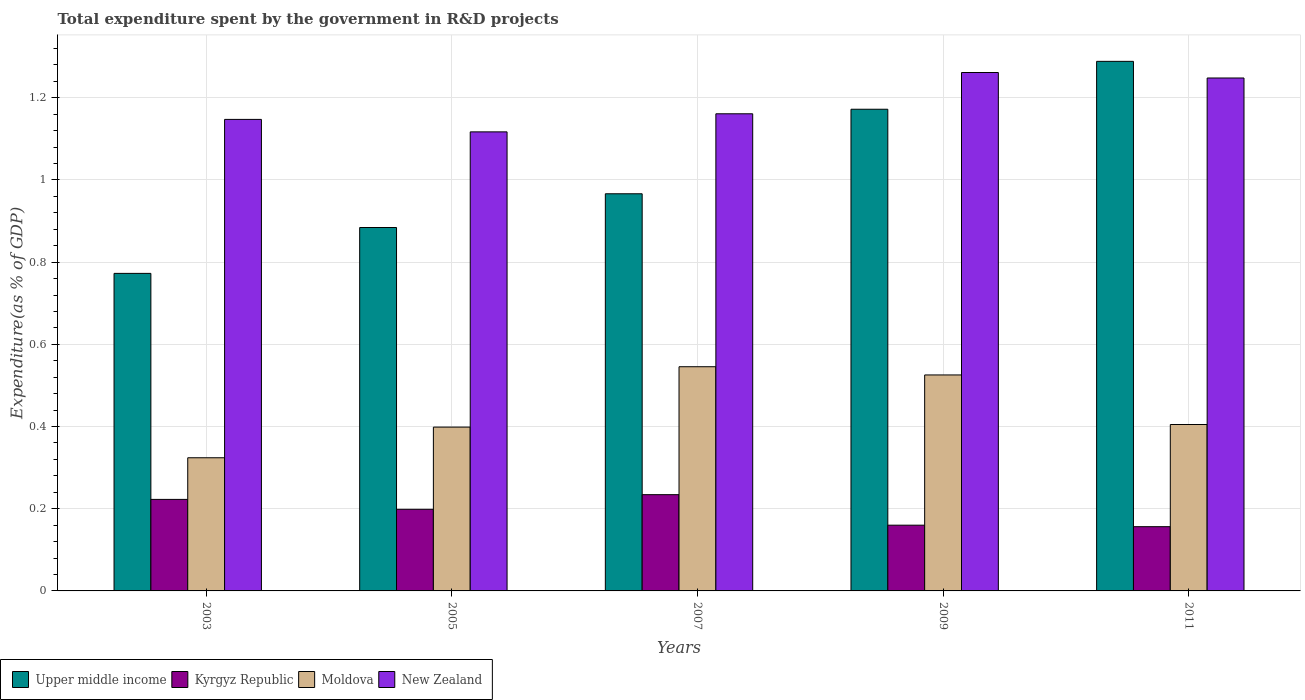How many different coloured bars are there?
Provide a short and direct response. 4. How many groups of bars are there?
Give a very brief answer. 5. Are the number of bars on each tick of the X-axis equal?
Make the answer very short. Yes. How many bars are there on the 1st tick from the left?
Offer a terse response. 4. How many bars are there on the 2nd tick from the right?
Provide a succinct answer. 4. What is the total expenditure spent by the government in R&D projects in Moldova in 2007?
Provide a short and direct response. 0.55. Across all years, what is the maximum total expenditure spent by the government in R&D projects in Upper middle income?
Offer a terse response. 1.29. Across all years, what is the minimum total expenditure spent by the government in R&D projects in Moldova?
Your answer should be compact. 0.32. In which year was the total expenditure spent by the government in R&D projects in Moldova maximum?
Provide a succinct answer. 2007. In which year was the total expenditure spent by the government in R&D projects in New Zealand minimum?
Give a very brief answer. 2005. What is the total total expenditure spent by the government in R&D projects in New Zealand in the graph?
Offer a very short reply. 5.94. What is the difference between the total expenditure spent by the government in R&D projects in Upper middle income in 2003 and that in 2011?
Make the answer very short. -0.52. What is the difference between the total expenditure spent by the government in R&D projects in Kyrgyz Republic in 2011 and the total expenditure spent by the government in R&D projects in Upper middle income in 2005?
Offer a very short reply. -0.73. What is the average total expenditure spent by the government in R&D projects in Moldova per year?
Give a very brief answer. 0.44. In the year 2005, what is the difference between the total expenditure spent by the government in R&D projects in Upper middle income and total expenditure spent by the government in R&D projects in New Zealand?
Your answer should be very brief. -0.23. What is the ratio of the total expenditure spent by the government in R&D projects in Upper middle income in 2007 to that in 2011?
Your response must be concise. 0.75. What is the difference between the highest and the second highest total expenditure spent by the government in R&D projects in Upper middle income?
Keep it short and to the point. 0.12. What is the difference between the highest and the lowest total expenditure spent by the government in R&D projects in Moldova?
Keep it short and to the point. 0.22. In how many years, is the total expenditure spent by the government in R&D projects in Moldova greater than the average total expenditure spent by the government in R&D projects in Moldova taken over all years?
Your answer should be compact. 2. Is the sum of the total expenditure spent by the government in R&D projects in Kyrgyz Republic in 2005 and 2009 greater than the maximum total expenditure spent by the government in R&D projects in Moldova across all years?
Provide a short and direct response. No. Is it the case that in every year, the sum of the total expenditure spent by the government in R&D projects in New Zealand and total expenditure spent by the government in R&D projects in Kyrgyz Republic is greater than the sum of total expenditure spent by the government in R&D projects in Moldova and total expenditure spent by the government in R&D projects in Upper middle income?
Your answer should be very brief. No. What does the 3rd bar from the left in 2003 represents?
Provide a succinct answer. Moldova. What does the 1st bar from the right in 2011 represents?
Give a very brief answer. New Zealand. Is it the case that in every year, the sum of the total expenditure spent by the government in R&D projects in Moldova and total expenditure spent by the government in R&D projects in Kyrgyz Republic is greater than the total expenditure spent by the government in R&D projects in Upper middle income?
Keep it short and to the point. No. How many bars are there?
Give a very brief answer. 20. Are all the bars in the graph horizontal?
Your response must be concise. No. How many years are there in the graph?
Make the answer very short. 5. Does the graph contain any zero values?
Provide a short and direct response. No. Does the graph contain grids?
Offer a terse response. Yes. Where does the legend appear in the graph?
Offer a terse response. Bottom left. How many legend labels are there?
Offer a terse response. 4. How are the legend labels stacked?
Offer a terse response. Horizontal. What is the title of the graph?
Your response must be concise. Total expenditure spent by the government in R&D projects. What is the label or title of the Y-axis?
Give a very brief answer. Expenditure(as % of GDP). What is the Expenditure(as % of GDP) of Upper middle income in 2003?
Give a very brief answer. 0.77. What is the Expenditure(as % of GDP) in Kyrgyz Republic in 2003?
Your response must be concise. 0.22. What is the Expenditure(as % of GDP) of Moldova in 2003?
Make the answer very short. 0.32. What is the Expenditure(as % of GDP) in New Zealand in 2003?
Offer a very short reply. 1.15. What is the Expenditure(as % of GDP) in Upper middle income in 2005?
Provide a succinct answer. 0.88. What is the Expenditure(as % of GDP) in Kyrgyz Republic in 2005?
Offer a very short reply. 0.2. What is the Expenditure(as % of GDP) of Moldova in 2005?
Your answer should be very brief. 0.4. What is the Expenditure(as % of GDP) of New Zealand in 2005?
Keep it short and to the point. 1.12. What is the Expenditure(as % of GDP) of Upper middle income in 2007?
Your answer should be very brief. 0.97. What is the Expenditure(as % of GDP) in Kyrgyz Republic in 2007?
Provide a succinct answer. 0.23. What is the Expenditure(as % of GDP) in Moldova in 2007?
Offer a terse response. 0.55. What is the Expenditure(as % of GDP) of New Zealand in 2007?
Keep it short and to the point. 1.16. What is the Expenditure(as % of GDP) in Upper middle income in 2009?
Make the answer very short. 1.17. What is the Expenditure(as % of GDP) of Kyrgyz Republic in 2009?
Provide a succinct answer. 0.16. What is the Expenditure(as % of GDP) in Moldova in 2009?
Give a very brief answer. 0.53. What is the Expenditure(as % of GDP) of New Zealand in 2009?
Give a very brief answer. 1.26. What is the Expenditure(as % of GDP) of Upper middle income in 2011?
Provide a short and direct response. 1.29. What is the Expenditure(as % of GDP) of Kyrgyz Republic in 2011?
Make the answer very short. 0.16. What is the Expenditure(as % of GDP) of Moldova in 2011?
Your response must be concise. 0.4. What is the Expenditure(as % of GDP) of New Zealand in 2011?
Offer a terse response. 1.25. Across all years, what is the maximum Expenditure(as % of GDP) in Upper middle income?
Offer a very short reply. 1.29. Across all years, what is the maximum Expenditure(as % of GDP) of Kyrgyz Republic?
Provide a short and direct response. 0.23. Across all years, what is the maximum Expenditure(as % of GDP) in Moldova?
Provide a succinct answer. 0.55. Across all years, what is the maximum Expenditure(as % of GDP) in New Zealand?
Provide a succinct answer. 1.26. Across all years, what is the minimum Expenditure(as % of GDP) of Upper middle income?
Your answer should be compact. 0.77. Across all years, what is the minimum Expenditure(as % of GDP) in Kyrgyz Republic?
Your answer should be compact. 0.16. Across all years, what is the minimum Expenditure(as % of GDP) in Moldova?
Provide a short and direct response. 0.32. Across all years, what is the minimum Expenditure(as % of GDP) of New Zealand?
Ensure brevity in your answer.  1.12. What is the total Expenditure(as % of GDP) of Upper middle income in the graph?
Offer a very short reply. 5.08. What is the total Expenditure(as % of GDP) of Kyrgyz Republic in the graph?
Your answer should be very brief. 0.97. What is the total Expenditure(as % of GDP) of Moldova in the graph?
Give a very brief answer. 2.2. What is the total Expenditure(as % of GDP) in New Zealand in the graph?
Your answer should be compact. 5.94. What is the difference between the Expenditure(as % of GDP) in Upper middle income in 2003 and that in 2005?
Your answer should be compact. -0.11. What is the difference between the Expenditure(as % of GDP) in Kyrgyz Republic in 2003 and that in 2005?
Provide a succinct answer. 0.02. What is the difference between the Expenditure(as % of GDP) in Moldova in 2003 and that in 2005?
Provide a short and direct response. -0.07. What is the difference between the Expenditure(as % of GDP) of New Zealand in 2003 and that in 2005?
Offer a very short reply. 0.03. What is the difference between the Expenditure(as % of GDP) in Upper middle income in 2003 and that in 2007?
Your response must be concise. -0.19. What is the difference between the Expenditure(as % of GDP) of Kyrgyz Republic in 2003 and that in 2007?
Provide a succinct answer. -0.01. What is the difference between the Expenditure(as % of GDP) of Moldova in 2003 and that in 2007?
Keep it short and to the point. -0.22. What is the difference between the Expenditure(as % of GDP) in New Zealand in 2003 and that in 2007?
Make the answer very short. -0.01. What is the difference between the Expenditure(as % of GDP) in Upper middle income in 2003 and that in 2009?
Offer a very short reply. -0.4. What is the difference between the Expenditure(as % of GDP) of Kyrgyz Republic in 2003 and that in 2009?
Your response must be concise. 0.06. What is the difference between the Expenditure(as % of GDP) of Moldova in 2003 and that in 2009?
Provide a succinct answer. -0.2. What is the difference between the Expenditure(as % of GDP) of New Zealand in 2003 and that in 2009?
Give a very brief answer. -0.11. What is the difference between the Expenditure(as % of GDP) in Upper middle income in 2003 and that in 2011?
Keep it short and to the point. -0.52. What is the difference between the Expenditure(as % of GDP) of Kyrgyz Republic in 2003 and that in 2011?
Offer a terse response. 0.07. What is the difference between the Expenditure(as % of GDP) of Moldova in 2003 and that in 2011?
Offer a terse response. -0.08. What is the difference between the Expenditure(as % of GDP) of New Zealand in 2003 and that in 2011?
Your response must be concise. -0.1. What is the difference between the Expenditure(as % of GDP) in Upper middle income in 2005 and that in 2007?
Offer a very short reply. -0.08. What is the difference between the Expenditure(as % of GDP) of Kyrgyz Republic in 2005 and that in 2007?
Your response must be concise. -0.04. What is the difference between the Expenditure(as % of GDP) in Moldova in 2005 and that in 2007?
Your answer should be very brief. -0.15. What is the difference between the Expenditure(as % of GDP) of New Zealand in 2005 and that in 2007?
Give a very brief answer. -0.04. What is the difference between the Expenditure(as % of GDP) in Upper middle income in 2005 and that in 2009?
Give a very brief answer. -0.29. What is the difference between the Expenditure(as % of GDP) of Kyrgyz Republic in 2005 and that in 2009?
Your answer should be very brief. 0.04. What is the difference between the Expenditure(as % of GDP) of Moldova in 2005 and that in 2009?
Give a very brief answer. -0.13. What is the difference between the Expenditure(as % of GDP) of New Zealand in 2005 and that in 2009?
Your answer should be compact. -0.14. What is the difference between the Expenditure(as % of GDP) of Upper middle income in 2005 and that in 2011?
Offer a very short reply. -0.4. What is the difference between the Expenditure(as % of GDP) in Kyrgyz Republic in 2005 and that in 2011?
Give a very brief answer. 0.04. What is the difference between the Expenditure(as % of GDP) of Moldova in 2005 and that in 2011?
Offer a terse response. -0.01. What is the difference between the Expenditure(as % of GDP) of New Zealand in 2005 and that in 2011?
Offer a very short reply. -0.13. What is the difference between the Expenditure(as % of GDP) in Upper middle income in 2007 and that in 2009?
Make the answer very short. -0.21. What is the difference between the Expenditure(as % of GDP) of Kyrgyz Republic in 2007 and that in 2009?
Ensure brevity in your answer.  0.07. What is the difference between the Expenditure(as % of GDP) of Moldova in 2007 and that in 2009?
Offer a very short reply. 0.02. What is the difference between the Expenditure(as % of GDP) in New Zealand in 2007 and that in 2009?
Provide a succinct answer. -0.1. What is the difference between the Expenditure(as % of GDP) in Upper middle income in 2007 and that in 2011?
Give a very brief answer. -0.32. What is the difference between the Expenditure(as % of GDP) of Kyrgyz Republic in 2007 and that in 2011?
Keep it short and to the point. 0.08. What is the difference between the Expenditure(as % of GDP) in Moldova in 2007 and that in 2011?
Offer a terse response. 0.14. What is the difference between the Expenditure(as % of GDP) of New Zealand in 2007 and that in 2011?
Offer a terse response. -0.09. What is the difference between the Expenditure(as % of GDP) of Upper middle income in 2009 and that in 2011?
Make the answer very short. -0.12. What is the difference between the Expenditure(as % of GDP) of Kyrgyz Republic in 2009 and that in 2011?
Provide a short and direct response. 0. What is the difference between the Expenditure(as % of GDP) of Moldova in 2009 and that in 2011?
Make the answer very short. 0.12. What is the difference between the Expenditure(as % of GDP) of New Zealand in 2009 and that in 2011?
Provide a succinct answer. 0.01. What is the difference between the Expenditure(as % of GDP) of Upper middle income in 2003 and the Expenditure(as % of GDP) of Kyrgyz Republic in 2005?
Your answer should be very brief. 0.57. What is the difference between the Expenditure(as % of GDP) in Upper middle income in 2003 and the Expenditure(as % of GDP) in Moldova in 2005?
Offer a very short reply. 0.37. What is the difference between the Expenditure(as % of GDP) in Upper middle income in 2003 and the Expenditure(as % of GDP) in New Zealand in 2005?
Your response must be concise. -0.34. What is the difference between the Expenditure(as % of GDP) in Kyrgyz Republic in 2003 and the Expenditure(as % of GDP) in Moldova in 2005?
Provide a succinct answer. -0.18. What is the difference between the Expenditure(as % of GDP) of Kyrgyz Republic in 2003 and the Expenditure(as % of GDP) of New Zealand in 2005?
Provide a succinct answer. -0.89. What is the difference between the Expenditure(as % of GDP) of Moldova in 2003 and the Expenditure(as % of GDP) of New Zealand in 2005?
Give a very brief answer. -0.79. What is the difference between the Expenditure(as % of GDP) in Upper middle income in 2003 and the Expenditure(as % of GDP) in Kyrgyz Republic in 2007?
Provide a short and direct response. 0.54. What is the difference between the Expenditure(as % of GDP) in Upper middle income in 2003 and the Expenditure(as % of GDP) in Moldova in 2007?
Your response must be concise. 0.23. What is the difference between the Expenditure(as % of GDP) in Upper middle income in 2003 and the Expenditure(as % of GDP) in New Zealand in 2007?
Make the answer very short. -0.39. What is the difference between the Expenditure(as % of GDP) of Kyrgyz Republic in 2003 and the Expenditure(as % of GDP) of Moldova in 2007?
Provide a succinct answer. -0.32. What is the difference between the Expenditure(as % of GDP) of Kyrgyz Republic in 2003 and the Expenditure(as % of GDP) of New Zealand in 2007?
Offer a terse response. -0.94. What is the difference between the Expenditure(as % of GDP) of Moldova in 2003 and the Expenditure(as % of GDP) of New Zealand in 2007?
Your answer should be compact. -0.84. What is the difference between the Expenditure(as % of GDP) of Upper middle income in 2003 and the Expenditure(as % of GDP) of Kyrgyz Republic in 2009?
Keep it short and to the point. 0.61. What is the difference between the Expenditure(as % of GDP) of Upper middle income in 2003 and the Expenditure(as % of GDP) of Moldova in 2009?
Your answer should be compact. 0.25. What is the difference between the Expenditure(as % of GDP) in Upper middle income in 2003 and the Expenditure(as % of GDP) in New Zealand in 2009?
Your response must be concise. -0.49. What is the difference between the Expenditure(as % of GDP) in Kyrgyz Republic in 2003 and the Expenditure(as % of GDP) in Moldova in 2009?
Offer a very short reply. -0.3. What is the difference between the Expenditure(as % of GDP) of Kyrgyz Republic in 2003 and the Expenditure(as % of GDP) of New Zealand in 2009?
Offer a terse response. -1.04. What is the difference between the Expenditure(as % of GDP) in Moldova in 2003 and the Expenditure(as % of GDP) in New Zealand in 2009?
Provide a succinct answer. -0.94. What is the difference between the Expenditure(as % of GDP) of Upper middle income in 2003 and the Expenditure(as % of GDP) of Kyrgyz Republic in 2011?
Keep it short and to the point. 0.62. What is the difference between the Expenditure(as % of GDP) of Upper middle income in 2003 and the Expenditure(as % of GDP) of Moldova in 2011?
Provide a short and direct response. 0.37. What is the difference between the Expenditure(as % of GDP) of Upper middle income in 2003 and the Expenditure(as % of GDP) of New Zealand in 2011?
Ensure brevity in your answer.  -0.48. What is the difference between the Expenditure(as % of GDP) in Kyrgyz Republic in 2003 and the Expenditure(as % of GDP) in Moldova in 2011?
Your answer should be compact. -0.18. What is the difference between the Expenditure(as % of GDP) in Kyrgyz Republic in 2003 and the Expenditure(as % of GDP) in New Zealand in 2011?
Keep it short and to the point. -1.03. What is the difference between the Expenditure(as % of GDP) of Moldova in 2003 and the Expenditure(as % of GDP) of New Zealand in 2011?
Provide a short and direct response. -0.92. What is the difference between the Expenditure(as % of GDP) in Upper middle income in 2005 and the Expenditure(as % of GDP) in Kyrgyz Republic in 2007?
Your answer should be compact. 0.65. What is the difference between the Expenditure(as % of GDP) of Upper middle income in 2005 and the Expenditure(as % of GDP) of Moldova in 2007?
Ensure brevity in your answer.  0.34. What is the difference between the Expenditure(as % of GDP) of Upper middle income in 2005 and the Expenditure(as % of GDP) of New Zealand in 2007?
Your answer should be compact. -0.28. What is the difference between the Expenditure(as % of GDP) in Kyrgyz Republic in 2005 and the Expenditure(as % of GDP) in Moldova in 2007?
Keep it short and to the point. -0.35. What is the difference between the Expenditure(as % of GDP) of Kyrgyz Republic in 2005 and the Expenditure(as % of GDP) of New Zealand in 2007?
Provide a succinct answer. -0.96. What is the difference between the Expenditure(as % of GDP) of Moldova in 2005 and the Expenditure(as % of GDP) of New Zealand in 2007?
Offer a terse response. -0.76. What is the difference between the Expenditure(as % of GDP) in Upper middle income in 2005 and the Expenditure(as % of GDP) in Kyrgyz Republic in 2009?
Offer a terse response. 0.72. What is the difference between the Expenditure(as % of GDP) of Upper middle income in 2005 and the Expenditure(as % of GDP) of Moldova in 2009?
Your answer should be very brief. 0.36. What is the difference between the Expenditure(as % of GDP) of Upper middle income in 2005 and the Expenditure(as % of GDP) of New Zealand in 2009?
Provide a short and direct response. -0.38. What is the difference between the Expenditure(as % of GDP) of Kyrgyz Republic in 2005 and the Expenditure(as % of GDP) of Moldova in 2009?
Give a very brief answer. -0.33. What is the difference between the Expenditure(as % of GDP) in Kyrgyz Republic in 2005 and the Expenditure(as % of GDP) in New Zealand in 2009?
Give a very brief answer. -1.06. What is the difference between the Expenditure(as % of GDP) in Moldova in 2005 and the Expenditure(as % of GDP) in New Zealand in 2009?
Offer a terse response. -0.86. What is the difference between the Expenditure(as % of GDP) of Upper middle income in 2005 and the Expenditure(as % of GDP) of Kyrgyz Republic in 2011?
Your response must be concise. 0.73. What is the difference between the Expenditure(as % of GDP) in Upper middle income in 2005 and the Expenditure(as % of GDP) in Moldova in 2011?
Your answer should be compact. 0.48. What is the difference between the Expenditure(as % of GDP) of Upper middle income in 2005 and the Expenditure(as % of GDP) of New Zealand in 2011?
Your answer should be very brief. -0.36. What is the difference between the Expenditure(as % of GDP) in Kyrgyz Republic in 2005 and the Expenditure(as % of GDP) in Moldova in 2011?
Provide a short and direct response. -0.21. What is the difference between the Expenditure(as % of GDP) of Kyrgyz Republic in 2005 and the Expenditure(as % of GDP) of New Zealand in 2011?
Offer a very short reply. -1.05. What is the difference between the Expenditure(as % of GDP) of Moldova in 2005 and the Expenditure(as % of GDP) of New Zealand in 2011?
Ensure brevity in your answer.  -0.85. What is the difference between the Expenditure(as % of GDP) of Upper middle income in 2007 and the Expenditure(as % of GDP) of Kyrgyz Republic in 2009?
Offer a terse response. 0.81. What is the difference between the Expenditure(as % of GDP) in Upper middle income in 2007 and the Expenditure(as % of GDP) in Moldova in 2009?
Your response must be concise. 0.44. What is the difference between the Expenditure(as % of GDP) of Upper middle income in 2007 and the Expenditure(as % of GDP) of New Zealand in 2009?
Ensure brevity in your answer.  -0.3. What is the difference between the Expenditure(as % of GDP) of Kyrgyz Republic in 2007 and the Expenditure(as % of GDP) of Moldova in 2009?
Provide a succinct answer. -0.29. What is the difference between the Expenditure(as % of GDP) in Kyrgyz Republic in 2007 and the Expenditure(as % of GDP) in New Zealand in 2009?
Make the answer very short. -1.03. What is the difference between the Expenditure(as % of GDP) in Moldova in 2007 and the Expenditure(as % of GDP) in New Zealand in 2009?
Provide a succinct answer. -0.72. What is the difference between the Expenditure(as % of GDP) in Upper middle income in 2007 and the Expenditure(as % of GDP) in Kyrgyz Republic in 2011?
Make the answer very short. 0.81. What is the difference between the Expenditure(as % of GDP) of Upper middle income in 2007 and the Expenditure(as % of GDP) of Moldova in 2011?
Ensure brevity in your answer.  0.56. What is the difference between the Expenditure(as % of GDP) of Upper middle income in 2007 and the Expenditure(as % of GDP) of New Zealand in 2011?
Offer a terse response. -0.28. What is the difference between the Expenditure(as % of GDP) of Kyrgyz Republic in 2007 and the Expenditure(as % of GDP) of Moldova in 2011?
Give a very brief answer. -0.17. What is the difference between the Expenditure(as % of GDP) of Kyrgyz Republic in 2007 and the Expenditure(as % of GDP) of New Zealand in 2011?
Offer a very short reply. -1.01. What is the difference between the Expenditure(as % of GDP) of Moldova in 2007 and the Expenditure(as % of GDP) of New Zealand in 2011?
Offer a terse response. -0.7. What is the difference between the Expenditure(as % of GDP) in Upper middle income in 2009 and the Expenditure(as % of GDP) in Kyrgyz Republic in 2011?
Provide a succinct answer. 1.02. What is the difference between the Expenditure(as % of GDP) of Upper middle income in 2009 and the Expenditure(as % of GDP) of Moldova in 2011?
Keep it short and to the point. 0.77. What is the difference between the Expenditure(as % of GDP) of Upper middle income in 2009 and the Expenditure(as % of GDP) of New Zealand in 2011?
Keep it short and to the point. -0.08. What is the difference between the Expenditure(as % of GDP) of Kyrgyz Republic in 2009 and the Expenditure(as % of GDP) of Moldova in 2011?
Provide a short and direct response. -0.24. What is the difference between the Expenditure(as % of GDP) of Kyrgyz Republic in 2009 and the Expenditure(as % of GDP) of New Zealand in 2011?
Offer a terse response. -1.09. What is the difference between the Expenditure(as % of GDP) in Moldova in 2009 and the Expenditure(as % of GDP) in New Zealand in 2011?
Offer a terse response. -0.72. What is the average Expenditure(as % of GDP) in Upper middle income per year?
Provide a short and direct response. 1.02. What is the average Expenditure(as % of GDP) in Kyrgyz Republic per year?
Give a very brief answer. 0.19. What is the average Expenditure(as % of GDP) of Moldova per year?
Your response must be concise. 0.44. What is the average Expenditure(as % of GDP) in New Zealand per year?
Make the answer very short. 1.19. In the year 2003, what is the difference between the Expenditure(as % of GDP) in Upper middle income and Expenditure(as % of GDP) in Kyrgyz Republic?
Provide a short and direct response. 0.55. In the year 2003, what is the difference between the Expenditure(as % of GDP) of Upper middle income and Expenditure(as % of GDP) of Moldova?
Keep it short and to the point. 0.45. In the year 2003, what is the difference between the Expenditure(as % of GDP) in Upper middle income and Expenditure(as % of GDP) in New Zealand?
Your answer should be compact. -0.37. In the year 2003, what is the difference between the Expenditure(as % of GDP) of Kyrgyz Republic and Expenditure(as % of GDP) of Moldova?
Ensure brevity in your answer.  -0.1. In the year 2003, what is the difference between the Expenditure(as % of GDP) in Kyrgyz Republic and Expenditure(as % of GDP) in New Zealand?
Make the answer very short. -0.92. In the year 2003, what is the difference between the Expenditure(as % of GDP) of Moldova and Expenditure(as % of GDP) of New Zealand?
Keep it short and to the point. -0.82. In the year 2005, what is the difference between the Expenditure(as % of GDP) in Upper middle income and Expenditure(as % of GDP) in Kyrgyz Republic?
Provide a short and direct response. 0.69. In the year 2005, what is the difference between the Expenditure(as % of GDP) in Upper middle income and Expenditure(as % of GDP) in Moldova?
Provide a succinct answer. 0.49. In the year 2005, what is the difference between the Expenditure(as % of GDP) in Upper middle income and Expenditure(as % of GDP) in New Zealand?
Your answer should be compact. -0.23. In the year 2005, what is the difference between the Expenditure(as % of GDP) in Kyrgyz Republic and Expenditure(as % of GDP) in Moldova?
Make the answer very short. -0.2. In the year 2005, what is the difference between the Expenditure(as % of GDP) in Kyrgyz Republic and Expenditure(as % of GDP) in New Zealand?
Your answer should be very brief. -0.92. In the year 2005, what is the difference between the Expenditure(as % of GDP) in Moldova and Expenditure(as % of GDP) in New Zealand?
Your answer should be compact. -0.72. In the year 2007, what is the difference between the Expenditure(as % of GDP) of Upper middle income and Expenditure(as % of GDP) of Kyrgyz Republic?
Your answer should be compact. 0.73. In the year 2007, what is the difference between the Expenditure(as % of GDP) in Upper middle income and Expenditure(as % of GDP) in Moldova?
Your answer should be very brief. 0.42. In the year 2007, what is the difference between the Expenditure(as % of GDP) of Upper middle income and Expenditure(as % of GDP) of New Zealand?
Your response must be concise. -0.19. In the year 2007, what is the difference between the Expenditure(as % of GDP) of Kyrgyz Republic and Expenditure(as % of GDP) of Moldova?
Make the answer very short. -0.31. In the year 2007, what is the difference between the Expenditure(as % of GDP) of Kyrgyz Republic and Expenditure(as % of GDP) of New Zealand?
Provide a succinct answer. -0.93. In the year 2007, what is the difference between the Expenditure(as % of GDP) in Moldova and Expenditure(as % of GDP) in New Zealand?
Your answer should be very brief. -0.62. In the year 2009, what is the difference between the Expenditure(as % of GDP) in Upper middle income and Expenditure(as % of GDP) in Kyrgyz Republic?
Provide a short and direct response. 1.01. In the year 2009, what is the difference between the Expenditure(as % of GDP) of Upper middle income and Expenditure(as % of GDP) of Moldova?
Keep it short and to the point. 0.65. In the year 2009, what is the difference between the Expenditure(as % of GDP) of Upper middle income and Expenditure(as % of GDP) of New Zealand?
Keep it short and to the point. -0.09. In the year 2009, what is the difference between the Expenditure(as % of GDP) in Kyrgyz Republic and Expenditure(as % of GDP) in Moldova?
Provide a short and direct response. -0.37. In the year 2009, what is the difference between the Expenditure(as % of GDP) of Kyrgyz Republic and Expenditure(as % of GDP) of New Zealand?
Your response must be concise. -1.1. In the year 2009, what is the difference between the Expenditure(as % of GDP) in Moldova and Expenditure(as % of GDP) in New Zealand?
Your response must be concise. -0.74. In the year 2011, what is the difference between the Expenditure(as % of GDP) of Upper middle income and Expenditure(as % of GDP) of Kyrgyz Republic?
Offer a very short reply. 1.13. In the year 2011, what is the difference between the Expenditure(as % of GDP) of Upper middle income and Expenditure(as % of GDP) of Moldova?
Your answer should be compact. 0.88. In the year 2011, what is the difference between the Expenditure(as % of GDP) of Upper middle income and Expenditure(as % of GDP) of New Zealand?
Provide a short and direct response. 0.04. In the year 2011, what is the difference between the Expenditure(as % of GDP) of Kyrgyz Republic and Expenditure(as % of GDP) of Moldova?
Keep it short and to the point. -0.25. In the year 2011, what is the difference between the Expenditure(as % of GDP) of Kyrgyz Republic and Expenditure(as % of GDP) of New Zealand?
Make the answer very short. -1.09. In the year 2011, what is the difference between the Expenditure(as % of GDP) in Moldova and Expenditure(as % of GDP) in New Zealand?
Your response must be concise. -0.84. What is the ratio of the Expenditure(as % of GDP) of Upper middle income in 2003 to that in 2005?
Ensure brevity in your answer.  0.87. What is the ratio of the Expenditure(as % of GDP) in Kyrgyz Republic in 2003 to that in 2005?
Offer a terse response. 1.12. What is the ratio of the Expenditure(as % of GDP) of Moldova in 2003 to that in 2005?
Your answer should be very brief. 0.81. What is the ratio of the Expenditure(as % of GDP) in New Zealand in 2003 to that in 2005?
Provide a short and direct response. 1.03. What is the ratio of the Expenditure(as % of GDP) of Upper middle income in 2003 to that in 2007?
Your answer should be compact. 0.8. What is the ratio of the Expenditure(as % of GDP) of Kyrgyz Republic in 2003 to that in 2007?
Your response must be concise. 0.95. What is the ratio of the Expenditure(as % of GDP) of Moldova in 2003 to that in 2007?
Provide a succinct answer. 0.59. What is the ratio of the Expenditure(as % of GDP) in Upper middle income in 2003 to that in 2009?
Provide a succinct answer. 0.66. What is the ratio of the Expenditure(as % of GDP) of Kyrgyz Republic in 2003 to that in 2009?
Offer a very short reply. 1.39. What is the ratio of the Expenditure(as % of GDP) in Moldova in 2003 to that in 2009?
Your answer should be very brief. 0.62. What is the ratio of the Expenditure(as % of GDP) in New Zealand in 2003 to that in 2009?
Provide a succinct answer. 0.91. What is the ratio of the Expenditure(as % of GDP) of Upper middle income in 2003 to that in 2011?
Offer a terse response. 0.6. What is the ratio of the Expenditure(as % of GDP) in Kyrgyz Republic in 2003 to that in 2011?
Your answer should be compact. 1.42. What is the ratio of the Expenditure(as % of GDP) of Moldova in 2003 to that in 2011?
Your answer should be very brief. 0.8. What is the ratio of the Expenditure(as % of GDP) in New Zealand in 2003 to that in 2011?
Offer a terse response. 0.92. What is the ratio of the Expenditure(as % of GDP) of Upper middle income in 2005 to that in 2007?
Offer a very short reply. 0.92. What is the ratio of the Expenditure(as % of GDP) of Kyrgyz Republic in 2005 to that in 2007?
Provide a short and direct response. 0.85. What is the ratio of the Expenditure(as % of GDP) of Moldova in 2005 to that in 2007?
Make the answer very short. 0.73. What is the ratio of the Expenditure(as % of GDP) in New Zealand in 2005 to that in 2007?
Provide a succinct answer. 0.96. What is the ratio of the Expenditure(as % of GDP) of Upper middle income in 2005 to that in 2009?
Provide a succinct answer. 0.75. What is the ratio of the Expenditure(as % of GDP) of Kyrgyz Republic in 2005 to that in 2009?
Make the answer very short. 1.24. What is the ratio of the Expenditure(as % of GDP) in Moldova in 2005 to that in 2009?
Make the answer very short. 0.76. What is the ratio of the Expenditure(as % of GDP) of New Zealand in 2005 to that in 2009?
Ensure brevity in your answer.  0.89. What is the ratio of the Expenditure(as % of GDP) of Upper middle income in 2005 to that in 2011?
Offer a very short reply. 0.69. What is the ratio of the Expenditure(as % of GDP) in Kyrgyz Republic in 2005 to that in 2011?
Offer a terse response. 1.27. What is the ratio of the Expenditure(as % of GDP) of Moldova in 2005 to that in 2011?
Your answer should be compact. 0.98. What is the ratio of the Expenditure(as % of GDP) in New Zealand in 2005 to that in 2011?
Your response must be concise. 0.9. What is the ratio of the Expenditure(as % of GDP) of Upper middle income in 2007 to that in 2009?
Provide a short and direct response. 0.82. What is the ratio of the Expenditure(as % of GDP) of Kyrgyz Republic in 2007 to that in 2009?
Keep it short and to the point. 1.46. What is the ratio of the Expenditure(as % of GDP) in Moldova in 2007 to that in 2009?
Provide a succinct answer. 1.04. What is the ratio of the Expenditure(as % of GDP) of New Zealand in 2007 to that in 2009?
Give a very brief answer. 0.92. What is the ratio of the Expenditure(as % of GDP) in Upper middle income in 2007 to that in 2011?
Make the answer very short. 0.75. What is the ratio of the Expenditure(as % of GDP) in Kyrgyz Republic in 2007 to that in 2011?
Your answer should be compact. 1.5. What is the ratio of the Expenditure(as % of GDP) in Moldova in 2007 to that in 2011?
Provide a succinct answer. 1.35. What is the ratio of the Expenditure(as % of GDP) in New Zealand in 2007 to that in 2011?
Offer a terse response. 0.93. What is the ratio of the Expenditure(as % of GDP) of Upper middle income in 2009 to that in 2011?
Provide a short and direct response. 0.91. What is the ratio of the Expenditure(as % of GDP) of Kyrgyz Republic in 2009 to that in 2011?
Ensure brevity in your answer.  1.02. What is the ratio of the Expenditure(as % of GDP) in Moldova in 2009 to that in 2011?
Offer a very short reply. 1.3. What is the ratio of the Expenditure(as % of GDP) of New Zealand in 2009 to that in 2011?
Provide a succinct answer. 1.01. What is the difference between the highest and the second highest Expenditure(as % of GDP) in Upper middle income?
Your answer should be very brief. 0.12. What is the difference between the highest and the second highest Expenditure(as % of GDP) in Kyrgyz Republic?
Provide a short and direct response. 0.01. What is the difference between the highest and the second highest Expenditure(as % of GDP) of New Zealand?
Your answer should be compact. 0.01. What is the difference between the highest and the lowest Expenditure(as % of GDP) in Upper middle income?
Provide a short and direct response. 0.52. What is the difference between the highest and the lowest Expenditure(as % of GDP) in Kyrgyz Republic?
Provide a short and direct response. 0.08. What is the difference between the highest and the lowest Expenditure(as % of GDP) of Moldova?
Keep it short and to the point. 0.22. What is the difference between the highest and the lowest Expenditure(as % of GDP) in New Zealand?
Make the answer very short. 0.14. 